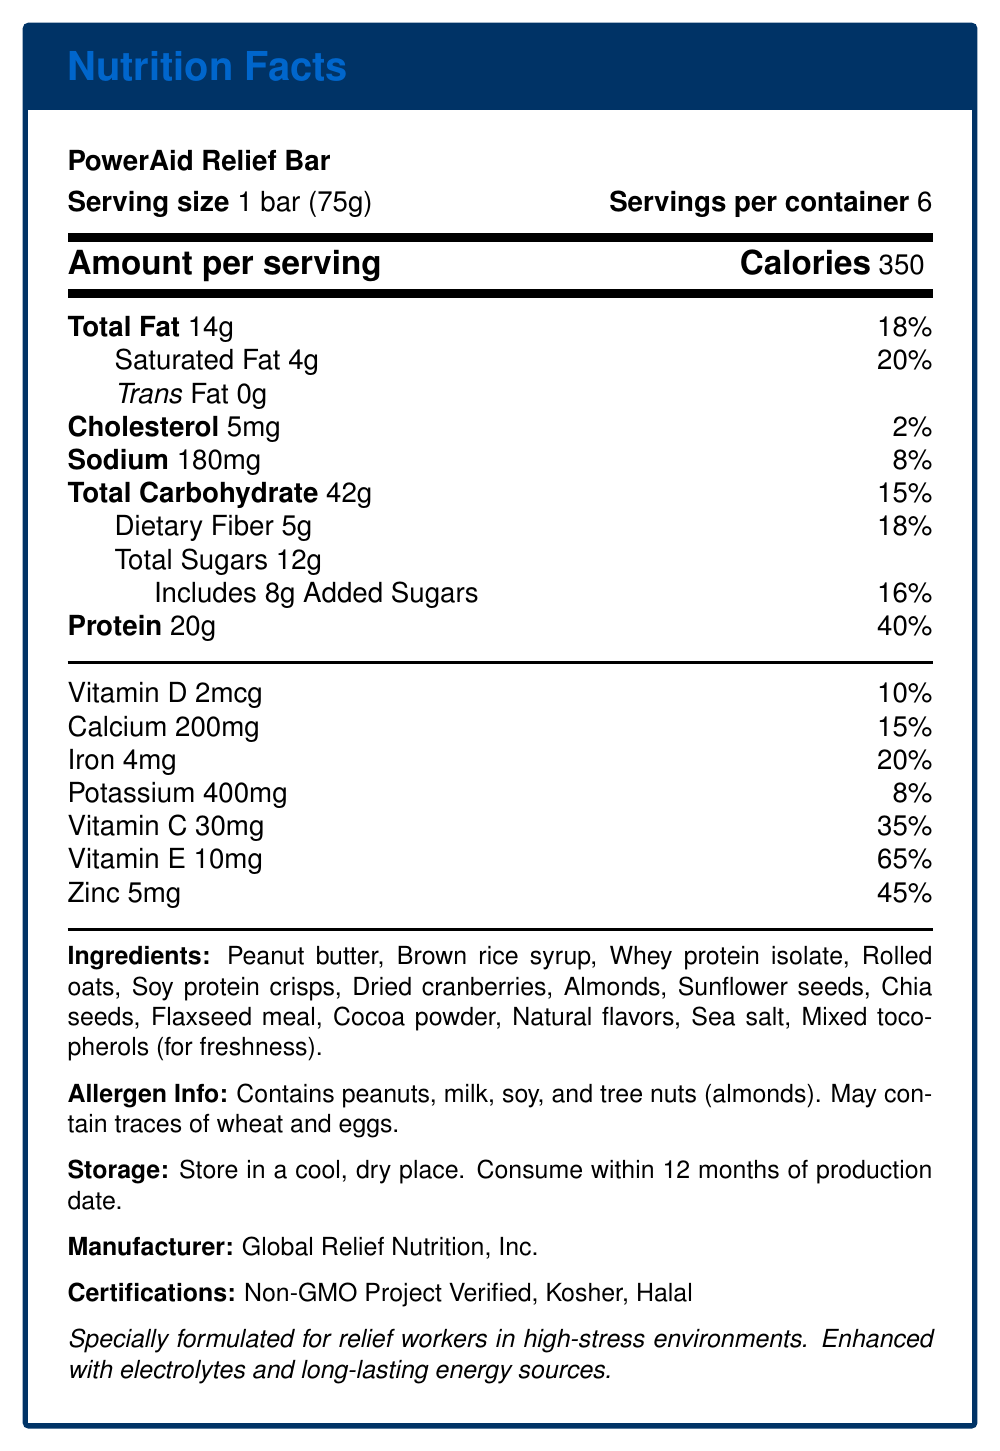What is the serving size of the PowerAid Relief Bar? The serving size is clearly indicated as "1 bar (75g)" in the document.
Answer: 1 bar (75g) How many servings are there per container of the PowerAid Relief Bar? The document states that there are 6 servings per container.
Answer: 6 What is the total amount of protein per serving? The document lists the protein content as 20g per serving.
Answer: 20g What is the amount of vitamin C in each bar? The document shows that each bar contains 30mg of vitamin C.
Answer: 30mg Which allergen information is provided for the PowerAid Relief Bar? The allergen information section explicitly states these details.
Answer: Contains peanuts, milk, soy, and tree nuts (almonds). May contain traces of wheat and eggs. What certifications does the PowerAid Relief Bar have?
I. Non-GMO Project Verified
II. Organic
III. Kosher
IV. Halal
A. I and II
B. II and III
C. I, III, and IV
D. I and IV The document mentions that the bar is Non-GMO Project Verified, Kosher, and Halal.
Answer: C How much saturated fat is in one bar?
A. 2g
B. 4g
C. 6g
D. 8g The document clearly lists the saturated fat content as 4g per bar.
Answer: B Is the PowerAid Relief Bar suitable for people with gluten allergies? The allergen info states it may contain traces of wheat, which is a source of gluten.
Answer: No Can you summarize the main features of the PowerAid Relief Bar? The summary covers the main nutritional information, certifications, ingredients, allergen information, and the target audience for the bar.
Answer: The PowerAid Relief Bar is a high-energy protein bar designed for relief workers in conflict zones. Each 75g bar provides 350 calories and contains 20g of protein, as well as various vitamins and minerals like vitamin C, vitamin E, and zinc. The bar has certifications such as Non-GMO Project Verified, Kosher, and Halal. It contains several ingredients, including peanut butter, whey protein isolate, and chia seeds, and includes allergen warnings for peanuts, milk, soy, and tree nuts (almonds). What is the exact production date of the PowerAid Relief Bar? The document does not provide any specific information about the production date, only that the bar should be consumed within 12 months of the production date.
Answer: Cannot be determined 